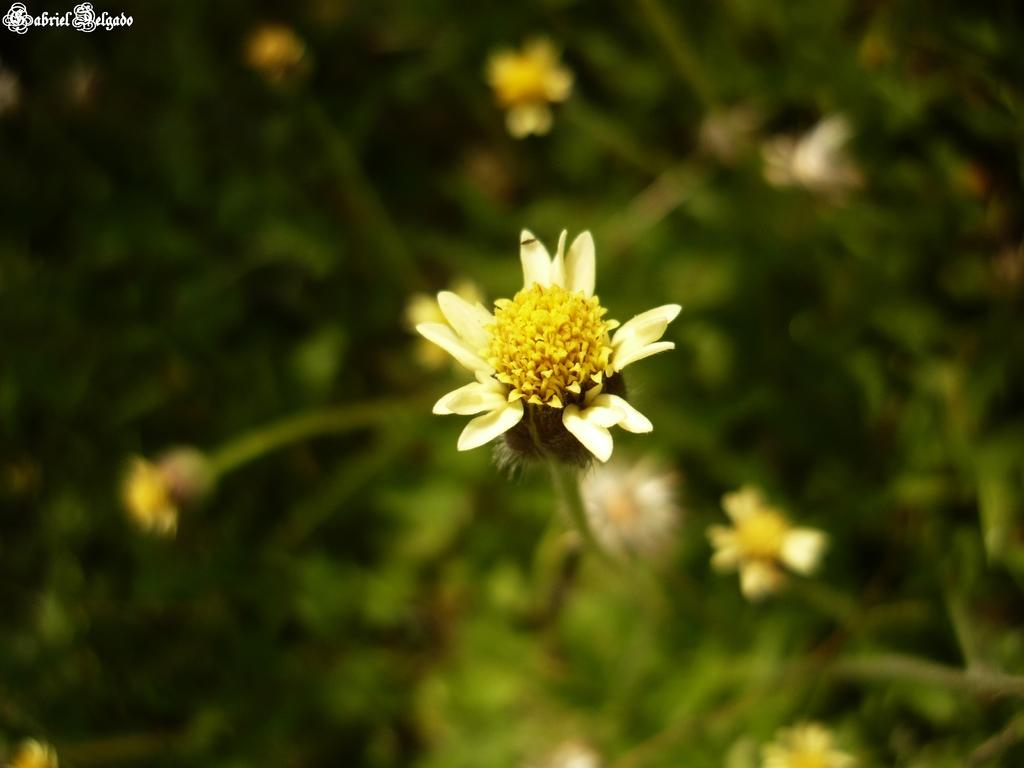What type of plants can be seen in the image? There are plants with flowers in the image. What colors are the flowers? The flowers are in white and yellow colors. Are there any plants visible in the background of the image? Yes, there are plants visible in the background of the image. How is the background of the image? The background of the image is blurred. Can you see any skin on the chickens in the image? There are no chickens present in the image; it features plants with flowers. What type of stamp is used to create the blurred effect in the background? The image does not show any stamps or techniques used to create the blurred effect; it is simply a characteristic of the image. 